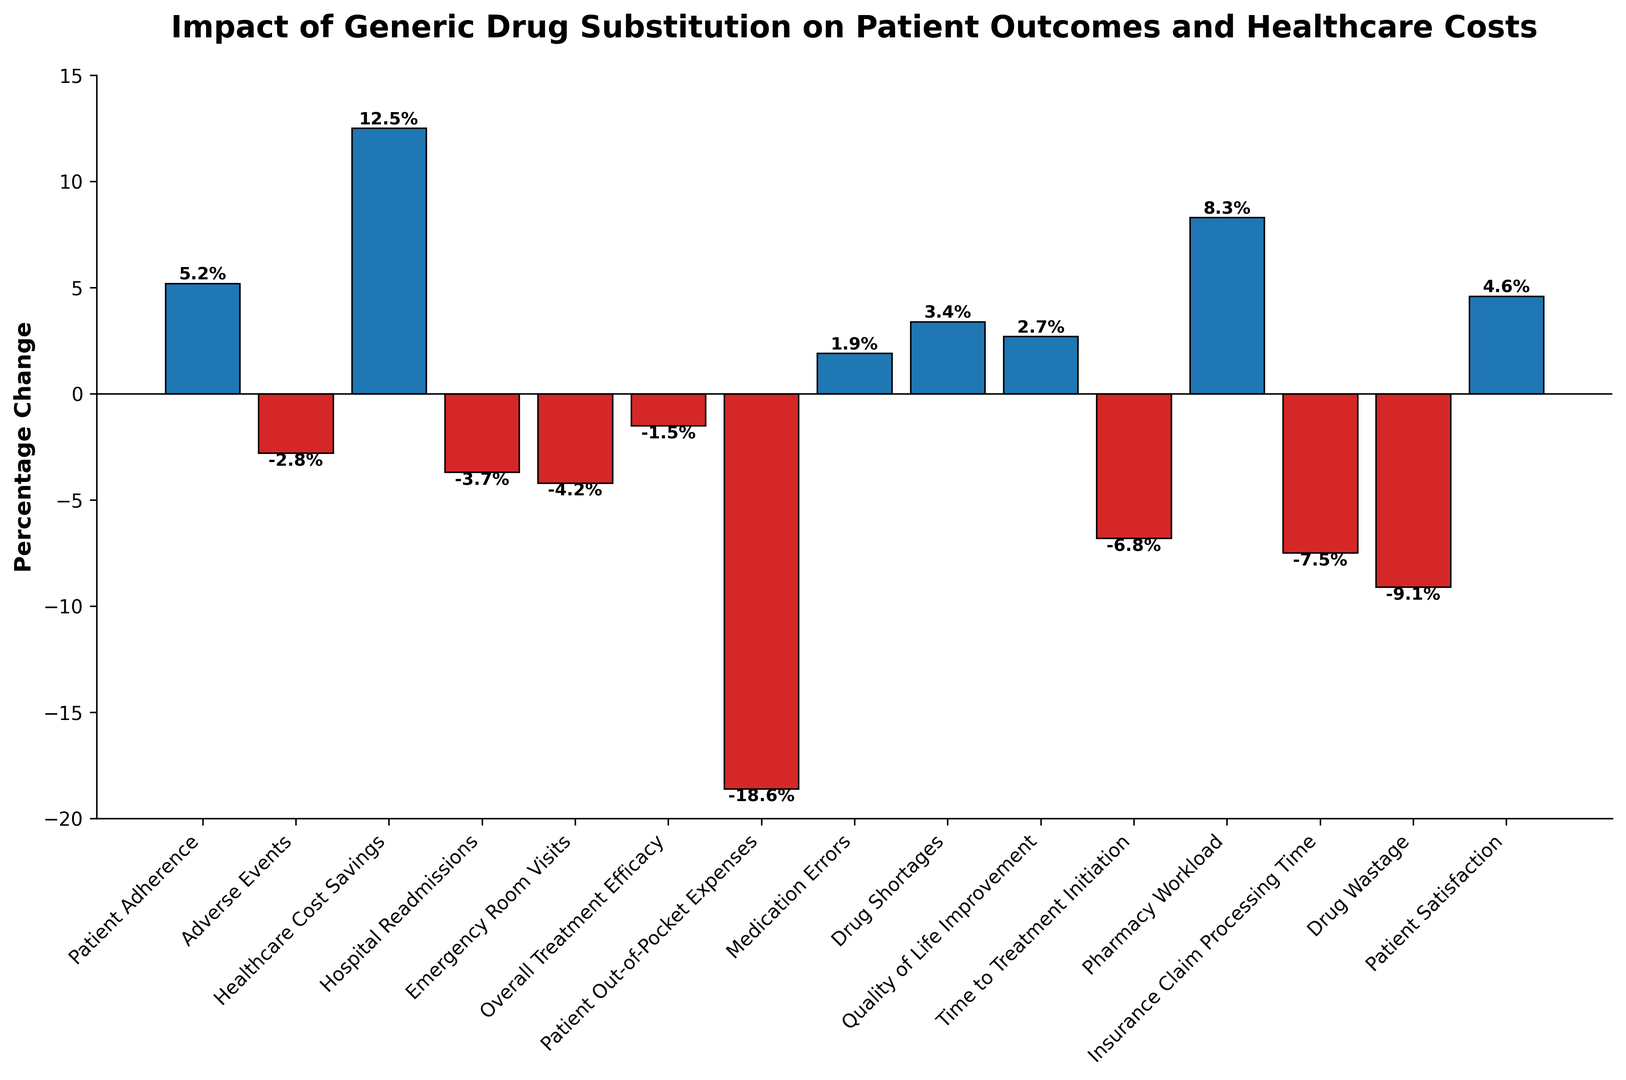What category has the highest positive percentage change? Looking at the chart, the bar for "Healthcare Cost Savings" is the tallest among the positive bars, indicating it has the highest positive percentage change.
Answer: Healthcare Cost Savings Which category has the most significant negative percentage change? Observing the chart, the bar for "Patient Out-of-Pocket Expenses" is the lowest among the negative bars, signifying it has the most significant negative percentage change.
Answer: Patient Out-of-Pocket Expenses What is the difference in percentage change between "Emergency Room Visits" and "Pharmacy Workload"? The percentage change for "Emergency Room Visits" is -4.2%, and for "Pharmacy Workload" it is 8.3%. The difference is calculated as 8.3% - (-4.2%) = 8.3% + 4.2% = 12.5%.
Answer: 12.5% What is the sum of the percentage changes in "Adverse Events" and "Overall Treatment Efficacy"? The percentage change for "Adverse Events" is -2.8%, and for "Overall Treatment Efficacy" it is -1.5%. Summing them gives -2.8% + (-1.5%) = -4.3%.
Answer: -4.3% Which category shows a positive percentage change but less than 3%? The categories "Patient Adherence," "Medication Errors," and "Quality of Life Improvement" all have positive bars under 3%. However, "Quality of Life Improvement" with 2.7% fits the criteria of being less than 3%.
Answer: Quality of Life Improvement Is the percentage change in "Patient Satisfaction" greater or less than "Patient Adherence"? The percentage change in "Patient Satisfaction" is 4.6%, and in "Patient Adherence" it is 5.2%. Since 4.6% is less than 5.2%, "Patient Satisfaction" is less than "Patient Adherence".
Answer: Less How many categories have a negative percentage change? To determine this, count the number of red bars on the chart. There are negative percentage changes for "Adverse Events," "Hospital Readmissions," "Emergency Room Visits," "Overall Treatment Efficacy," "Patient Out-of-Pocket Expenses," "Time to Treatment Initiation," "Insurance Claim Processing Time," and "Drug Wastage," totaling 8 categories.
Answer: 8 What is the average percentage change among the negative values? First sum the negative changes: (-2.8) + (-3.7) + (-4.2) + (-1.5) + (-18.6) + (-6.8) + (-7.5) + (-9.1) = -54.2. Divide this by the number of negative values, which is 8: -54.2 / 8 = -6.775%.
Answer: -6.775% What is the combined percentage change for "Emergency Room Visits" and "Insurance Claim Processing Time"? The percentage change for "Emergency Room Visits" is -4.2%, and for "Insurance Claim Processing Time" it is -7.5%. The combined change is -4.2% + (-7.5%) = -11.7%.
Answer: -11.7% 